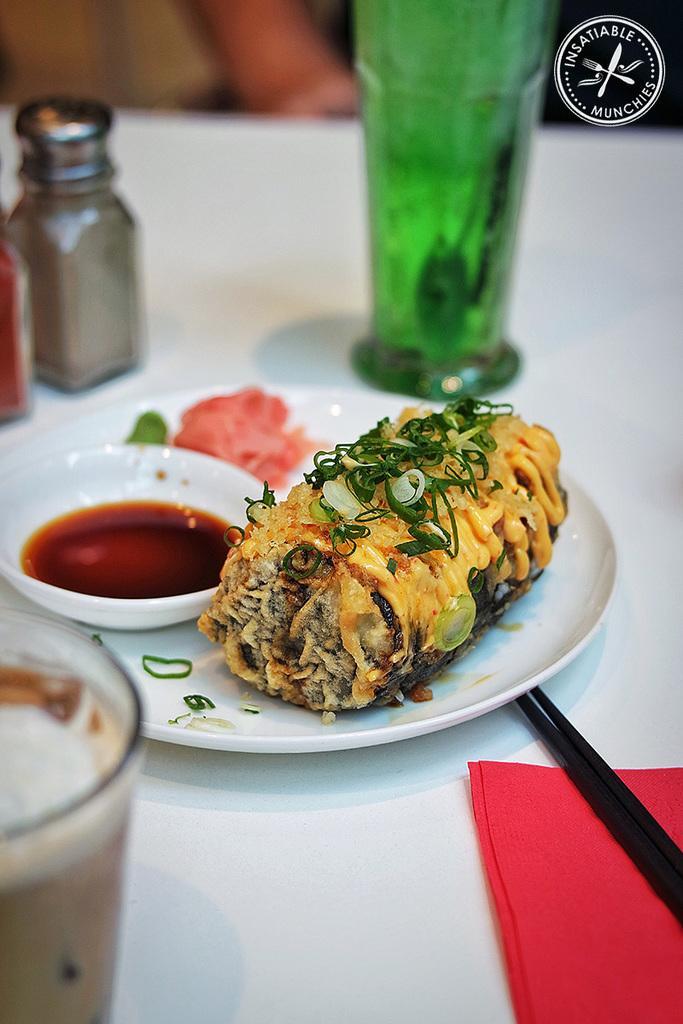Can you describe this image briefly? Here we can see food on plate, there is sauce in a bowl and there is a drink in a glass here we can see a bottle of water all placed on the table, here at the bottom right side we can see chopsticks 